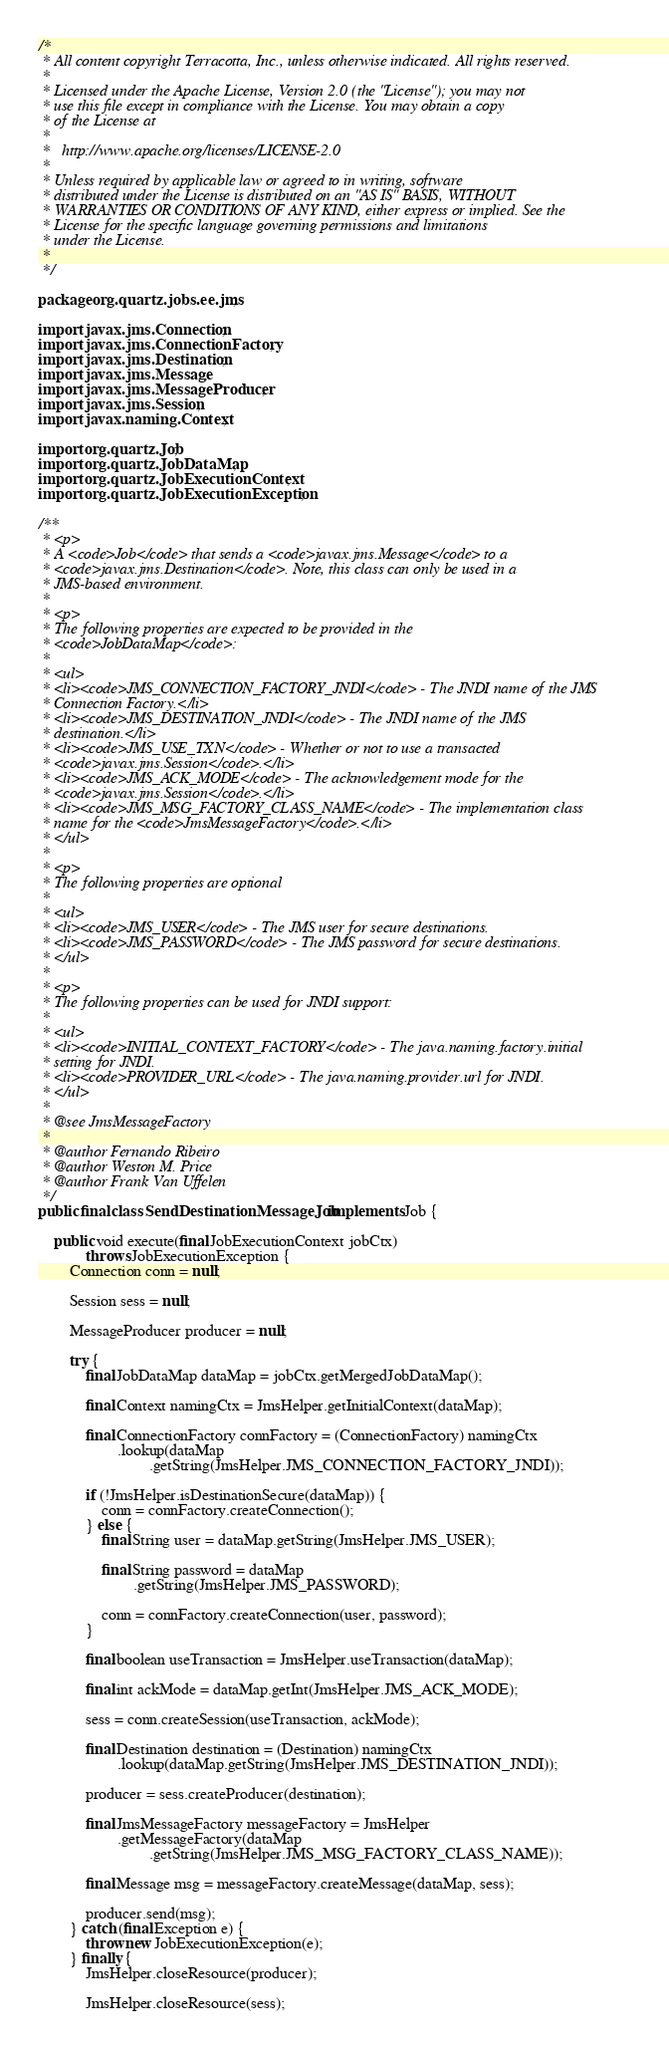Convert code to text. <code><loc_0><loc_0><loc_500><loc_500><_Java_>/* 
 * All content copyright Terracotta, Inc., unless otherwise indicated. All rights reserved.
 * 
 * Licensed under the Apache License, Version 2.0 (the "License"); you may not 
 * use this file except in compliance with the License. You may obtain a copy 
 * of the License at 
 * 
 *   http://www.apache.org/licenses/LICENSE-2.0 
 *   
 * Unless required by applicable law or agreed to in writing, software 
 * distributed under the License is distributed on an "AS IS" BASIS, WITHOUT 
 * WARRANTIES OR CONDITIONS OF ANY KIND, either express or implied. See the 
 * License for the specific language governing permissions and limitations 
 * under the License.
 * 
 */

package org.quartz.jobs.ee.jms;

import javax.jms.Connection;
import javax.jms.ConnectionFactory;
import javax.jms.Destination;
import javax.jms.Message;
import javax.jms.MessageProducer;
import javax.jms.Session;
import javax.naming.Context;

import org.quartz.Job;
import org.quartz.JobDataMap;
import org.quartz.JobExecutionContext;
import org.quartz.JobExecutionException;

/**
 * <p>
 * A <code>Job</code> that sends a <code>javax.jms.Message</code> to a
 * <code>javax.jms.Destination</code>. Note, this class can only be used in a
 * JMS-based environment.
 * 
 * <p>
 * The following properties are expected to be provided in the
 * <code>JobDataMap</code>:
 * 
 * <ul>
 * <li><code>JMS_CONNECTION_FACTORY_JNDI</code> - The JNDI name of the JMS
 * Connection Factory.</li>
 * <li><code>JMS_DESTINATION_JNDI</code> - The JNDI name of the JMS
 * destination.</li>
 * <li><code>JMS_USE_TXN</code> - Whether or not to use a transacted
 * <code>javax.jms.Session</code>.</li>
 * <li><code>JMS_ACK_MODE</code> - The acknowledgement mode for the
 * <code>javax.jms.Session</code>.</li>
 * <li><code>JMS_MSG_FACTORY_CLASS_NAME</code> - The implementation class
 * name for the <code>JmsMessageFactory</code>.</li>
 * </ul>
 * 
 * <p>
 * The following properties are optional
 * 
 * <ul>
 * <li><code>JMS_USER</code> - The JMS user for secure destinations.
 * <li><code>JMS_PASSWORD</code> - The JMS password for secure destinations.
 * </ul>
 * 
 * <p>
 * The following properties can be used for JNDI support:
 * 
 * <ul>
 * <li><code>INITIAL_CONTEXT_FACTORY</code> - The java.naming.factory.initial
 * setting for JNDI.
 * <li><code>PROVIDER_URL</code> - The java.naming.provider.url for JNDI.
 * </ul>
 * 
 * @see JmsMessageFactory
 * 
 * @author Fernando Ribeiro
 * @author Weston M. Price
 * @author Frank Van Uffelen
 */
public final class SendDestinationMessageJob implements Job {

    public void execute(final JobExecutionContext jobCtx)
            throws JobExecutionException {
        Connection conn = null;

        Session sess = null;

        MessageProducer producer = null;

        try {
            final JobDataMap dataMap = jobCtx.getMergedJobDataMap();

            final Context namingCtx = JmsHelper.getInitialContext(dataMap);

            final ConnectionFactory connFactory = (ConnectionFactory) namingCtx
                    .lookup(dataMap
                            .getString(JmsHelper.JMS_CONNECTION_FACTORY_JNDI));

            if (!JmsHelper.isDestinationSecure(dataMap)) {
                conn = connFactory.createConnection();
            } else {
                final String user = dataMap.getString(JmsHelper.JMS_USER);

                final String password = dataMap
                        .getString(JmsHelper.JMS_PASSWORD);

                conn = connFactory.createConnection(user, password);
            }

            final boolean useTransaction = JmsHelper.useTransaction(dataMap);

            final int ackMode = dataMap.getInt(JmsHelper.JMS_ACK_MODE);

            sess = conn.createSession(useTransaction, ackMode);

            final Destination destination = (Destination) namingCtx
                    .lookup(dataMap.getString(JmsHelper.JMS_DESTINATION_JNDI));

            producer = sess.createProducer(destination);

            final JmsMessageFactory messageFactory = JmsHelper
                    .getMessageFactory(dataMap
                            .getString(JmsHelper.JMS_MSG_FACTORY_CLASS_NAME));

            final Message msg = messageFactory.createMessage(dataMap, sess);

            producer.send(msg);
        } catch (final Exception e) {
            throw new JobExecutionException(e);
        } finally {
            JmsHelper.closeResource(producer);

            JmsHelper.closeResource(sess);
</code> 